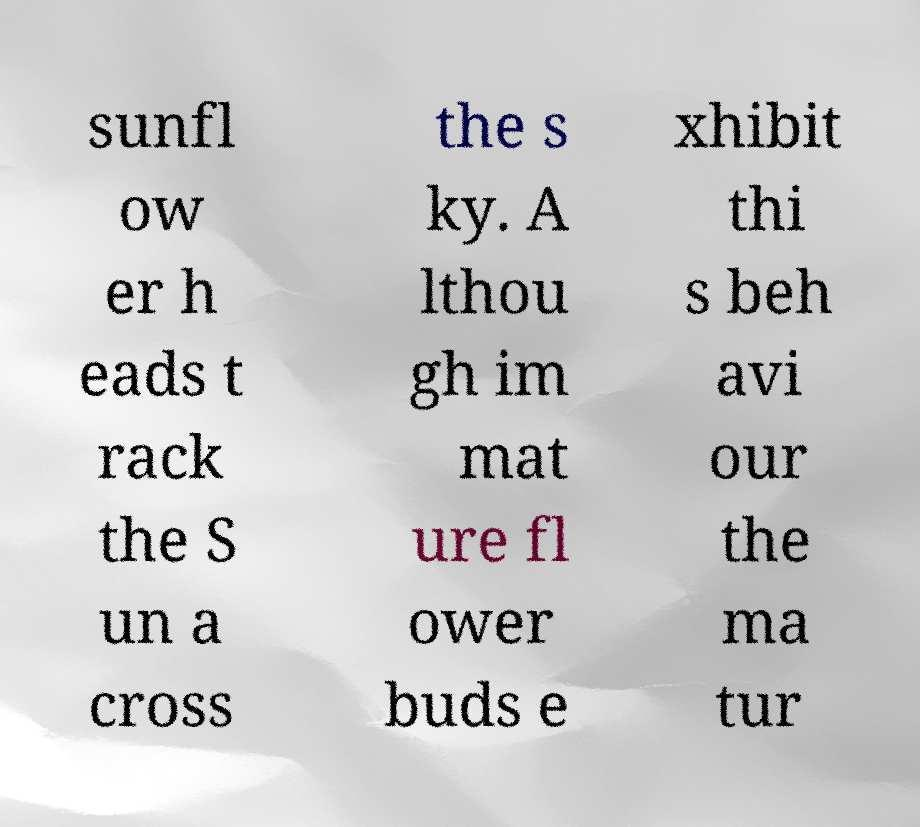For documentation purposes, I need the text within this image transcribed. Could you provide that? sunfl ow er h eads t rack the S un a cross the s ky. A lthou gh im mat ure fl ower buds e xhibit thi s beh avi our the ma tur 